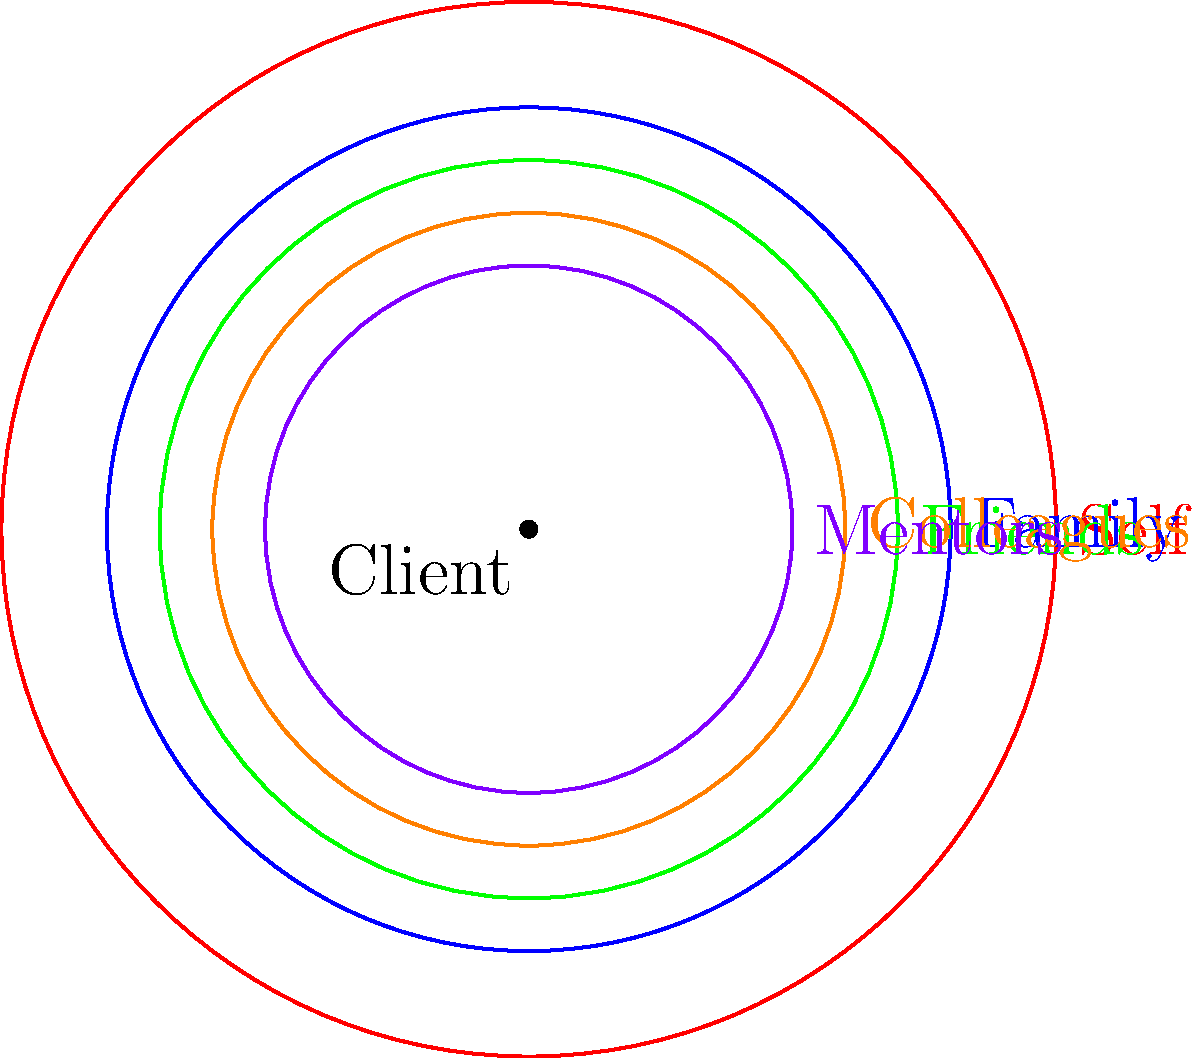In the context of addressing Imposter Syndrome, analyze the radial diagram representing a client's support network. Which group appears to be the most influential external support system, and how might this impact the client's self-esteem and confidence-building process? To analyze the radial diagram and determine the most influential external support system:

1. Observe the concentric circles representing different levels of influence or closeness to the client.
2. Identify the labeled groups: Self, Family, Friends, Colleagues, and Mentors.
3. Compare the proximity of each group to the center (client):
   - Self is at the center (not considered external)
   - Family is the closest external circle
   - Friends are the next closest
   - Colleagues follow
   - Mentors are the furthest

4. Conclude that Family is the most influential external support system due to its closest proximity to the client.

5. Consider the impact on the client's self-esteem and confidence-building:
   - Strong family support can provide a stable foundation for self-worth
   - Close family ties may offer validation and encouragement
   - Family members might have known the client longest, potentially countering negative self-perceptions
   - A supportive family environment can create a safe space for the client to address Imposter Syndrome

6. Recognize that while Family appears most influential, a holistic approach involving all support systems would be beneficial in addressing Imposter Syndrome.
Answer: Family; provides stable foundation for self-worth and validation, potentially countering Imposter Syndrome. 